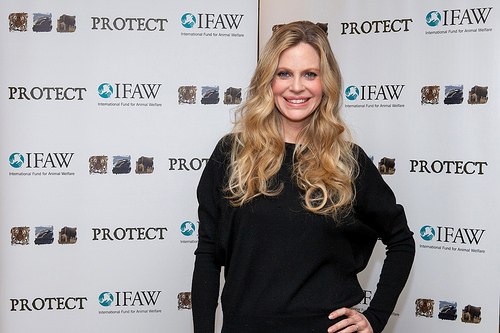<image>
Is there a woman behind the backdrop? No. The woman is not behind the backdrop. From this viewpoint, the woman appears to be positioned elsewhere in the scene. 